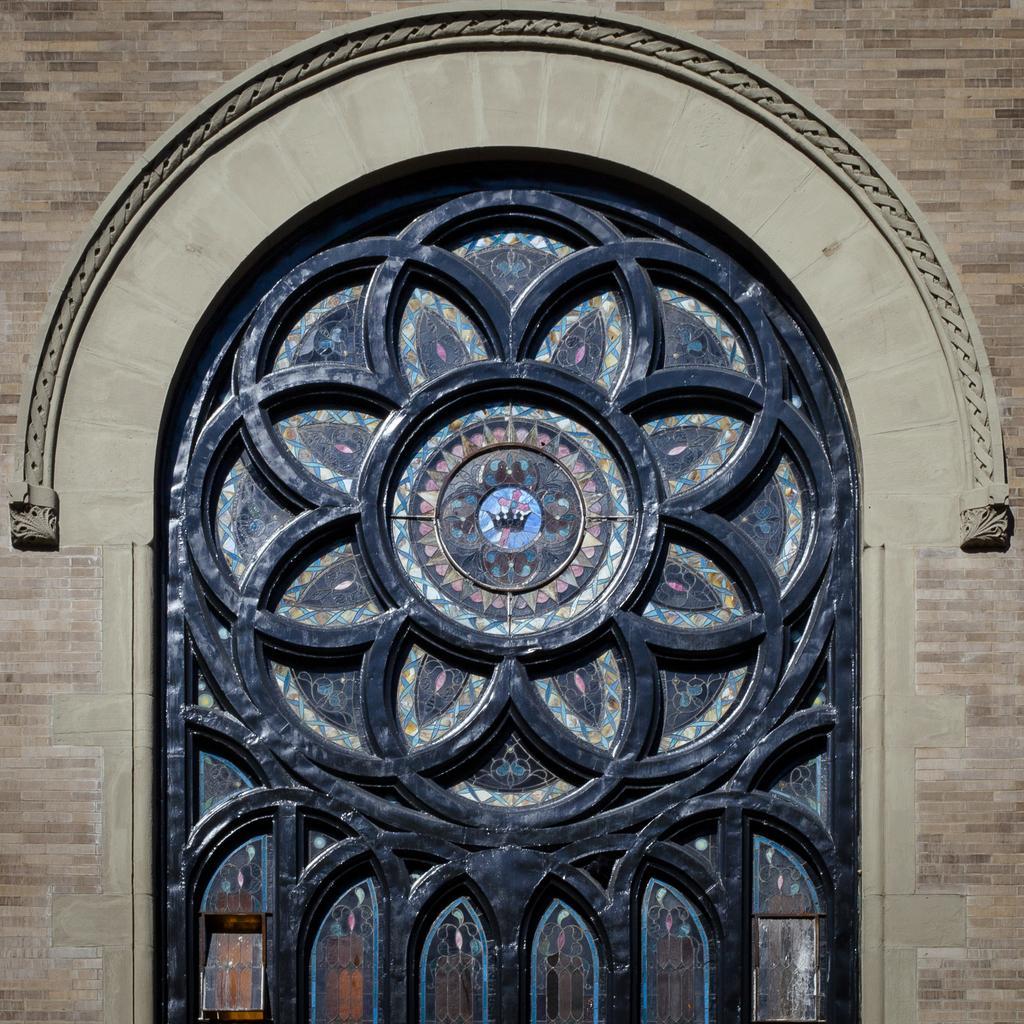Please provide a concise description of this image. In this image I can see the wall and in the centre of it I can see number of glasses and designs on it. 